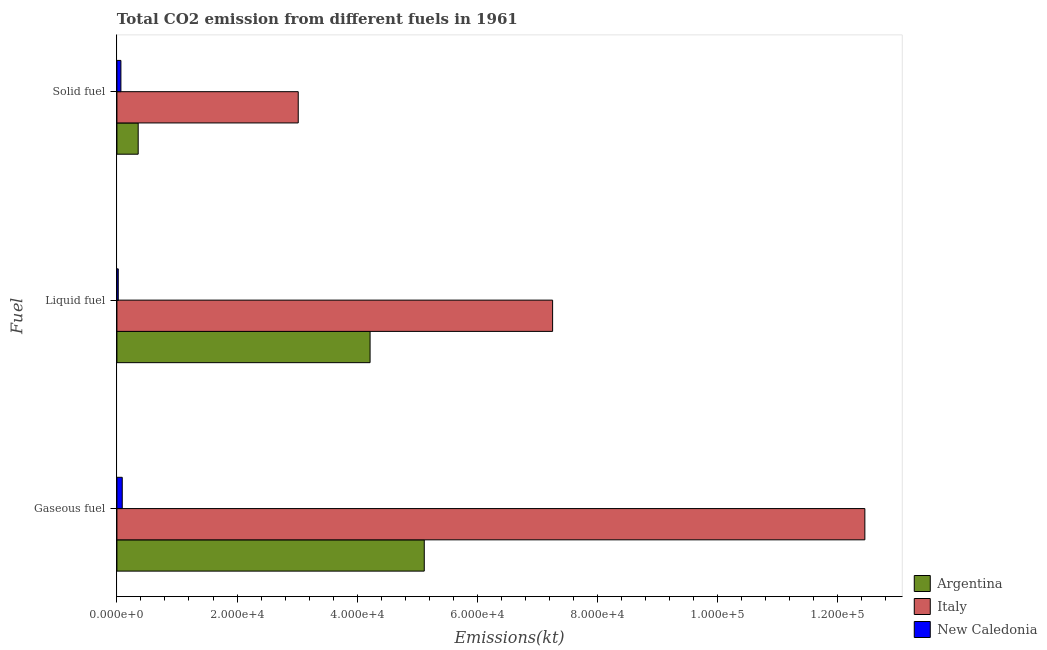How many different coloured bars are there?
Offer a very short reply. 3. How many groups of bars are there?
Provide a short and direct response. 3. Are the number of bars per tick equal to the number of legend labels?
Your response must be concise. Yes. Are the number of bars on each tick of the Y-axis equal?
Offer a very short reply. Yes. How many bars are there on the 2nd tick from the top?
Provide a succinct answer. 3. How many bars are there on the 3rd tick from the bottom?
Your answer should be very brief. 3. What is the label of the 3rd group of bars from the top?
Provide a short and direct response. Gaseous fuel. What is the amount of co2 emissions from liquid fuel in Italy?
Your answer should be very brief. 7.26e+04. Across all countries, what is the maximum amount of co2 emissions from solid fuel?
Make the answer very short. 3.02e+04. Across all countries, what is the minimum amount of co2 emissions from liquid fuel?
Provide a short and direct response. 223.69. In which country was the amount of co2 emissions from gaseous fuel minimum?
Ensure brevity in your answer.  New Caledonia. What is the total amount of co2 emissions from liquid fuel in the graph?
Give a very brief answer. 1.15e+05. What is the difference between the amount of co2 emissions from gaseous fuel in Argentina and that in Italy?
Your response must be concise. -7.34e+04. What is the difference between the amount of co2 emissions from liquid fuel in Italy and the amount of co2 emissions from gaseous fuel in New Caledonia?
Your answer should be compact. 7.17e+04. What is the average amount of co2 emissions from solid fuel per country?
Ensure brevity in your answer.  1.15e+04. What is the difference between the amount of co2 emissions from solid fuel and amount of co2 emissions from liquid fuel in New Caledonia?
Ensure brevity in your answer.  440.04. What is the ratio of the amount of co2 emissions from liquid fuel in Italy to that in New Caledonia?
Give a very brief answer. 324.34. Is the amount of co2 emissions from liquid fuel in New Caledonia less than that in Argentina?
Ensure brevity in your answer.  Yes. Is the difference between the amount of co2 emissions from gaseous fuel in Argentina and New Caledonia greater than the difference between the amount of co2 emissions from solid fuel in Argentina and New Caledonia?
Make the answer very short. Yes. What is the difference between the highest and the second highest amount of co2 emissions from gaseous fuel?
Your response must be concise. 7.34e+04. What is the difference between the highest and the lowest amount of co2 emissions from gaseous fuel?
Give a very brief answer. 1.24e+05. Is the sum of the amount of co2 emissions from gaseous fuel in Italy and New Caledonia greater than the maximum amount of co2 emissions from liquid fuel across all countries?
Make the answer very short. Yes. Is it the case that in every country, the sum of the amount of co2 emissions from gaseous fuel and amount of co2 emissions from liquid fuel is greater than the amount of co2 emissions from solid fuel?
Provide a short and direct response. Yes. What is the difference between two consecutive major ticks on the X-axis?
Give a very brief answer. 2.00e+04. Are the values on the major ticks of X-axis written in scientific E-notation?
Provide a short and direct response. Yes. Does the graph contain any zero values?
Offer a very short reply. No. Does the graph contain grids?
Your answer should be compact. No. Where does the legend appear in the graph?
Offer a terse response. Bottom right. How many legend labels are there?
Your response must be concise. 3. What is the title of the graph?
Give a very brief answer. Total CO2 emission from different fuels in 1961. Does "El Salvador" appear as one of the legend labels in the graph?
Provide a succinct answer. No. What is the label or title of the X-axis?
Your answer should be very brief. Emissions(kt). What is the label or title of the Y-axis?
Provide a short and direct response. Fuel. What is the Emissions(kt) in Argentina in Gaseous fuel?
Provide a short and direct response. 5.12e+04. What is the Emissions(kt) in Italy in Gaseous fuel?
Offer a very short reply. 1.25e+05. What is the Emissions(kt) of New Caledonia in Gaseous fuel?
Your response must be concise. 887.41. What is the Emissions(kt) in Argentina in Liquid fuel?
Ensure brevity in your answer.  4.22e+04. What is the Emissions(kt) of Italy in Liquid fuel?
Ensure brevity in your answer.  7.26e+04. What is the Emissions(kt) in New Caledonia in Liquid fuel?
Provide a short and direct response. 223.69. What is the Emissions(kt) in Argentina in Solid fuel?
Ensure brevity in your answer.  3542.32. What is the Emissions(kt) in Italy in Solid fuel?
Your answer should be compact. 3.02e+04. What is the Emissions(kt) in New Caledonia in Solid fuel?
Make the answer very short. 663.73. Across all Fuel, what is the maximum Emissions(kt) in Argentina?
Your answer should be very brief. 5.12e+04. Across all Fuel, what is the maximum Emissions(kt) of Italy?
Offer a terse response. 1.25e+05. Across all Fuel, what is the maximum Emissions(kt) in New Caledonia?
Provide a succinct answer. 887.41. Across all Fuel, what is the minimum Emissions(kt) of Argentina?
Give a very brief answer. 3542.32. Across all Fuel, what is the minimum Emissions(kt) of Italy?
Ensure brevity in your answer.  3.02e+04. Across all Fuel, what is the minimum Emissions(kt) of New Caledonia?
Offer a very short reply. 223.69. What is the total Emissions(kt) in Argentina in the graph?
Offer a terse response. 9.69e+04. What is the total Emissions(kt) in Italy in the graph?
Offer a very short reply. 2.27e+05. What is the total Emissions(kt) in New Caledonia in the graph?
Offer a terse response. 1774.83. What is the difference between the Emissions(kt) in Argentina in Gaseous fuel and that in Liquid fuel?
Give a very brief answer. 9024.49. What is the difference between the Emissions(kt) of Italy in Gaseous fuel and that in Liquid fuel?
Keep it short and to the point. 5.20e+04. What is the difference between the Emissions(kt) of New Caledonia in Gaseous fuel and that in Liquid fuel?
Your answer should be compact. 663.73. What is the difference between the Emissions(kt) of Argentina in Gaseous fuel and that in Solid fuel?
Keep it short and to the point. 4.76e+04. What is the difference between the Emissions(kt) of Italy in Gaseous fuel and that in Solid fuel?
Ensure brevity in your answer.  9.44e+04. What is the difference between the Emissions(kt) in New Caledonia in Gaseous fuel and that in Solid fuel?
Your answer should be very brief. 223.69. What is the difference between the Emissions(kt) in Argentina in Liquid fuel and that in Solid fuel?
Keep it short and to the point. 3.86e+04. What is the difference between the Emissions(kt) of Italy in Liquid fuel and that in Solid fuel?
Provide a short and direct response. 4.24e+04. What is the difference between the Emissions(kt) of New Caledonia in Liquid fuel and that in Solid fuel?
Make the answer very short. -440.04. What is the difference between the Emissions(kt) of Argentina in Gaseous fuel and the Emissions(kt) of Italy in Liquid fuel?
Ensure brevity in your answer.  -2.14e+04. What is the difference between the Emissions(kt) of Argentina in Gaseous fuel and the Emissions(kt) of New Caledonia in Liquid fuel?
Your answer should be very brief. 5.10e+04. What is the difference between the Emissions(kt) of Italy in Gaseous fuel and the Emissions(kt) of New Caledonia in Liquid fuel?
Your answer should be very brief. 1.24e+05. What is the difference between the Emissions(kt) of Argentina in Gaseous fuel and the Emissions(kt) of Italy in Solid fuel?
Provide a short and direct response. 2.10e+04. What is the difference between the Emissions(kt) in Argentina in Gaseous fuel and the Emissions(kt) in New Caledonia in Solid fuel?
Keep it short and to the point. 5.05e+04. What is the difference between the Emissions(kt) of Italy in Gaseous fuel and the Emissions(kt) of New Caledonia in Solid fuel?
Your answer should be very brief. 1.24e+05. What is the difference between the Emissions(kt) of Argentina in Liquid fuel and the Emissions(kt) of Italy in Solid fuel?
Make the answer very short. 1.20e+04. What is the difference between the Emissions(kt) in Argentina in Liquid fuel and the Emissions(kt) in New Caledonia in Solid fuel?
Keep it short and to the point. 4.15e+04. What is the difference between the Emissions(kt) in Italy in Liquid fuel and the Emissions(kt) in New Caledonia in Solid fuel?
Offer a terse response. 7.19e+04. What is the average Emissions(kt) of Argentina per Fuel?
Your answer should be compact. 3.23e+04. What is the average Emissions(kt) in Italy per Fuel?
Provide a short and direct response. 7.58e+04. What is the average Emissions(kt) in New Caledonia per Fuel?
Ensure brevity in your answer.  591.61. What is the difference between the Emissions(kt) of Argentina and Emissions(kt) of Italy in Gaseous fuel?
Ensure brevity in your answer.  -7.34e+04. What is the difference between the Emissions(kt) of Argentina and Emissions(kt) of New Caledonia in Gaseous fuel?
Your response must be concise. 5.03e+04. What is the difference between the Emissions(kt) in Italy and Emissions(kt) in New Caledonia in Gaseous fuel?
Keep it short and to the point. 1.24e+05. What is the difference between the Emissions(kt) in Argentina and Emissions(kt) in Italy in Liquid fuel?
Your response must be concise. -3.04e+04. What is the difference between the Emissions(kt) in Argentina and Emissions(kt) in New Caledonia in Liquid fuel?
Provide a short and direct response. 4.19e+04. What is the difference between the Emissions(kt) of Italy and Emissions(kt) of New Caledonia in Liquid fuel?
Make the answer very short. 7.23e+04. What is the difference between the Emissions(kt) in Argentina and Emissions(kt) in Italy in Solid fuel?
Your answer should be compact. -2.67e+04. What is the difference between the Emissions(kt) in Argentina and Emissions(kt) in New Caledonia in Solid fuel?
Your answer should be compact. 2878.59. What is the difference between the Emissions(kt) of Italy and Emissions(kt) of New Caledonia in Solid fuel?
Ensure brevity in your answer.  2.95e+04. What is the ratio of the Emissions(kt) of Argentina in Gaseous fuel to that in Liquid fuel?
Your answer should be compact. 1.21. What is the ratio of the Emissions(kt) in Italy in Gaseous fuel to that in Liquid fuel?
Your response must be concise. 1.72. What is the ratio of the Emissions(kt) of New Caledonia in Gaseous fuel to that in Liquid fuel?
Your answer should be compact. 3.97. What is the ratio of the Emissions(kt) in Argentina in Gaseous fuel to that in Solid fuel?
Keep it short and to the point. 14.45. What is the ratio of the Emissions(kt) of Italy in Gaseous fuel to that in Solid fuel?
Keep it short and to the point. 4.12. What is the ratio of the Emissions(kt) of New Caledonia in Gaseous fuel to that in Solid fuel?
Ensure brevity in your answer.  1.34. What is the ratio of the Emissions(kt) in Argentina in Liquid fuel to that in Solid fuel?
Your answer should be compact. 11.9. What is the ratio of the Emissions(kt) of Italy in Liquid fuel to that in Solid fuel?
Keep it short and to the point. 2.4. What is the ratio of the Emissions(kt) of New Caledonia in Liquid fuel to that in Solid fuel?
Your answer should be very brief. 0.34. What is the difference between the highest and the second highest Emissions(kt) of Argentina?
Provide a succinct answer. 9024.49. What is the difference between the highest and the second highest Emissions(kt) of Italy?
Your answer should be very brief. 5.20e+04. What is the difference between the highest and the second highest Emissions(kt) in New Caledonia?
Provide a succinct answer. 223.69. What is the difference between the highest and the lowest Emissions(kt) in Argentina?
Offer a very short reply. 4.76e+04. What is the difference between the highest and the lowest Emissions(kt) in Italy?
Ensure brevity in your answer.  9.44e+04. What is the difference between the highest and the lowest Emissions(kt) of New Caledonia?
Your answer should be very brief. 663.73. 